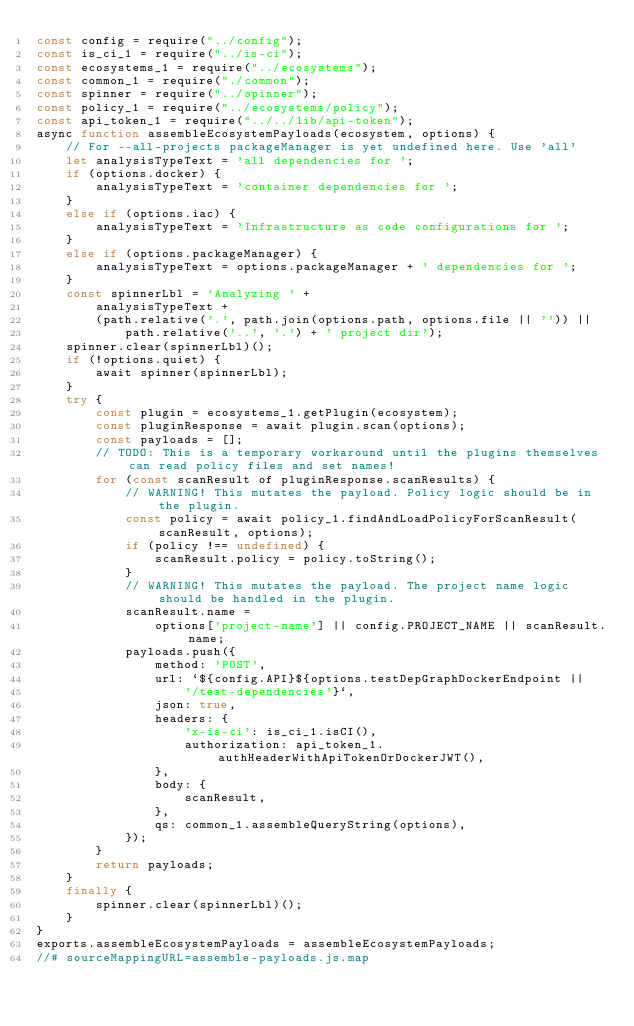Convert code to text. <code><loc_0><loc_0><loc_500><loc_500><_JavaScript_>const config = require("../config");
const is_ci_1 = require("../is-ci");
const ecosystems_1 = require("../ecosystems");
const common_1 = require("./common");
const spinner = require("../spinner");
const policy_1 = require("../ecosystems/policy");
const api_token_1 = require("../../lib/api-token");
async function assembleEcosystemPayloads(ecosystem, options) {
    // For --all-projects packageManager is yet undefined here. Use 'all'
    let analysisTypeText = 'all dependencies for ';
    if (options.docker) {
        analysisTypeText = 'container dependencies for ';
    }
    else if (options.iac) {
        analysisTypeText = 'Infrastructure as code configurations for ';
    }
    else if (options.packageManager) {
        analysisTypeText = options.packageManager + ' dependencies for ';
    }
    const spinnerLbl = 'Analyzing ' +
        analysisTypeText +
        (path.relative('.', path.join(options.path, options.file || '')) ||
            path.relative('..', '.') + ' project dir');
    spinner.clear(spinnerLbl)();
    if (!options.quiet) {
        await spinner(spinnerLbl);
    }
    try {
        const plugin = ecosystems_1.getPlugin(ecosystem);
        const pluginResponse = await plugin.scan(options);
        const payloads = [];
        // TODO: This is a temporary workaround until the plugins themselves can read policy files and set names!
        for (const scanResult of pluginResponse.scanResults) {
            // WARNING! This mutates the payload. Policy logic should be in the plugin.
            const policy = await policy_1.findAndLoadPolicyForScanResult(scanResult, options);
            if (policy !== undefined) {
                scanResult.policy = policy.toString();
            }
            // WARNING! This mutates the payload. The project name logic should be handled in the plugin.
            scanResult.name =
                options['project-name'] || config.PROJECT_NAME || scanResult.name;
            payloads.push({
                method: 'POST',
                url: `${config.API}${options.testDepGraphDockerEndpoint ||
                    '/test-dependencies'}`,
                json: true,
                headers: {
                    'x-is-ci': is_ci_1.isCI(),
                    authorization: api_token_1.authHeaderWithApiTokenOrDockerJWT(),
                },
                body: {
                    scanResult,
                },
                qs: common_1.assembleQueryString(options),
            });
        }
        return payloads;
    }
    finally {
        spinner.clear(spinnerLbl)();
    }
}
exports.assembleEcosystemPayloads = assembleEcosystemPayloads;
//# sourceMappingURL=assemble-payloads.js.map</code> 